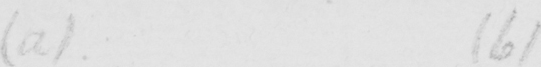Transcribe the text shown in this historical manuscript line. ( a )   ( b ) 